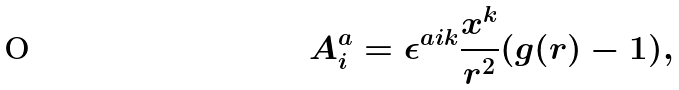<formula> <loc_0><loc_0><loc_500><loc_500>A ^ { a } _ { i } = \epsilon ^ { a i k } \frac { x ^ { k } } { r ^ { 2 } } ( g ( r ) - 1 ) ,</formula> 